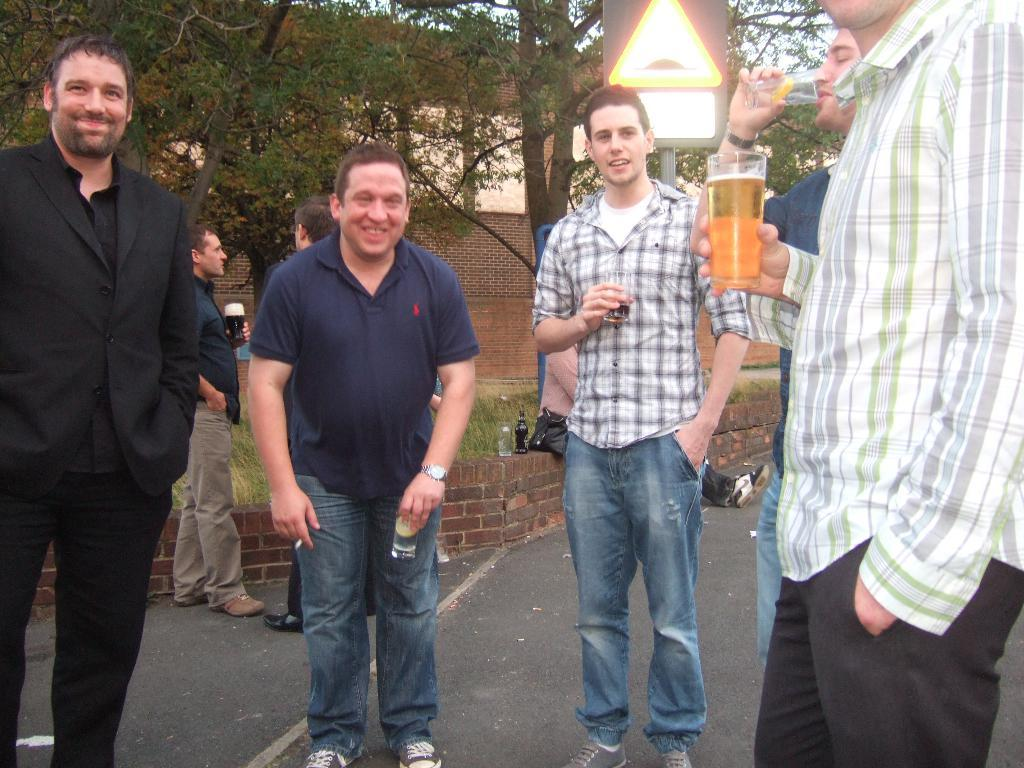How many men are visible in the image? There are five men standing in the image. What is the man in the shirt holding in his hand? The man in the shirt is holding a glass in his hand. Are there any other men visible in the image besides the first five? Yes, there are two more men standing behind the first five men. What type of vegetation can be seen in the image? Trees are present in the image. What type of metal can be seen on the hill in the image? There is no hill or metal present in the image. 